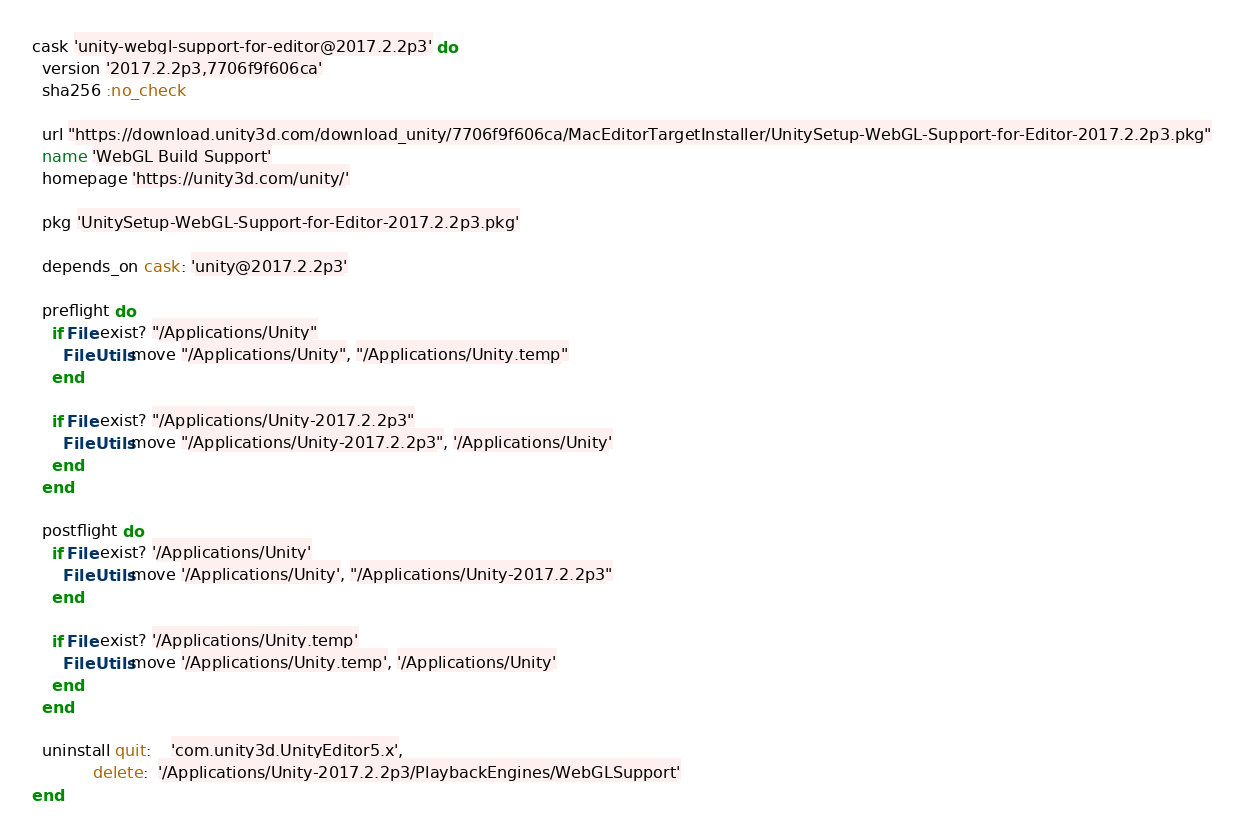Convert code to text. <code><loc_0><loc_0><loc_500><loc_500><_Ruby_>cask 'unity-webgl-support-for-editor@2017.2.2p3' do
  version '2017.2.2p3,7706f9f606ca'
  sha256 :no_check

  url "https://download.unity3d.com/download_unity/7706f9f606ca/MacEditorTargetInstaller/UnitySetup-WebGL-Support-for-Editor-2017.2.2p3.pkg"
  name 'WebGL Build Support'
  homepage 'https://unity3d.com/unity/'

  pkg 'UnitySetup-WebGL-Support-for-Editor-2017.2.2p3.pkg'

  depends_on cask: 'unity@2017.2.2p3'

  preflight do
    if File.exist? "/Applications/Unity"
      FileUtils.move "/Applications/Unity", "/Applications/Unity.temp"
    end

    if File.exist? "/Applications/Unity-2017.2.2p3"
      FileUtils.move "/Applications/Unity-2017.2.2p3", '/Applications/Unity'
    end
  end

  postflight do
    if File.exist? '/Applications/Unity'
      FileUtils.move '/Applications/Unity', "/Applications/Unity-2017.2.2p3"
    end

    if File.exist? '/Applications/Unity.temp'
      FileUtils.move '/Applications/Unity.temp', '/Applications/Unity'
    end
  end

  uninstall quit:    'com.unity3d.UnityEditor5.x',
            delete:  '/Applications/Unity-2017.2.2p3/PlaybackEngines/WebGLSupport'
end
</code> 